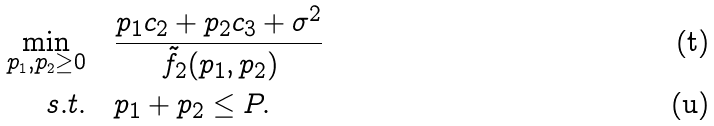Convert formula to latex. <formula><loc_0><loc_0><loc_500><loc_500>\min _ { p _ { 1 } , p _ { 2 } \geq 0 } & \quad \frac { p _ { 1 } c _ { 2 } + p _ { 2 } c _ { 3 } + \sigma ^ { 2 } } { \tilde { f } _ { 2 } ( p _ { 1 } , p _ { 2 } ) } \\ s . t . & \quad p _ { 1 } + p _ { 2 } \leq P .</formula> 